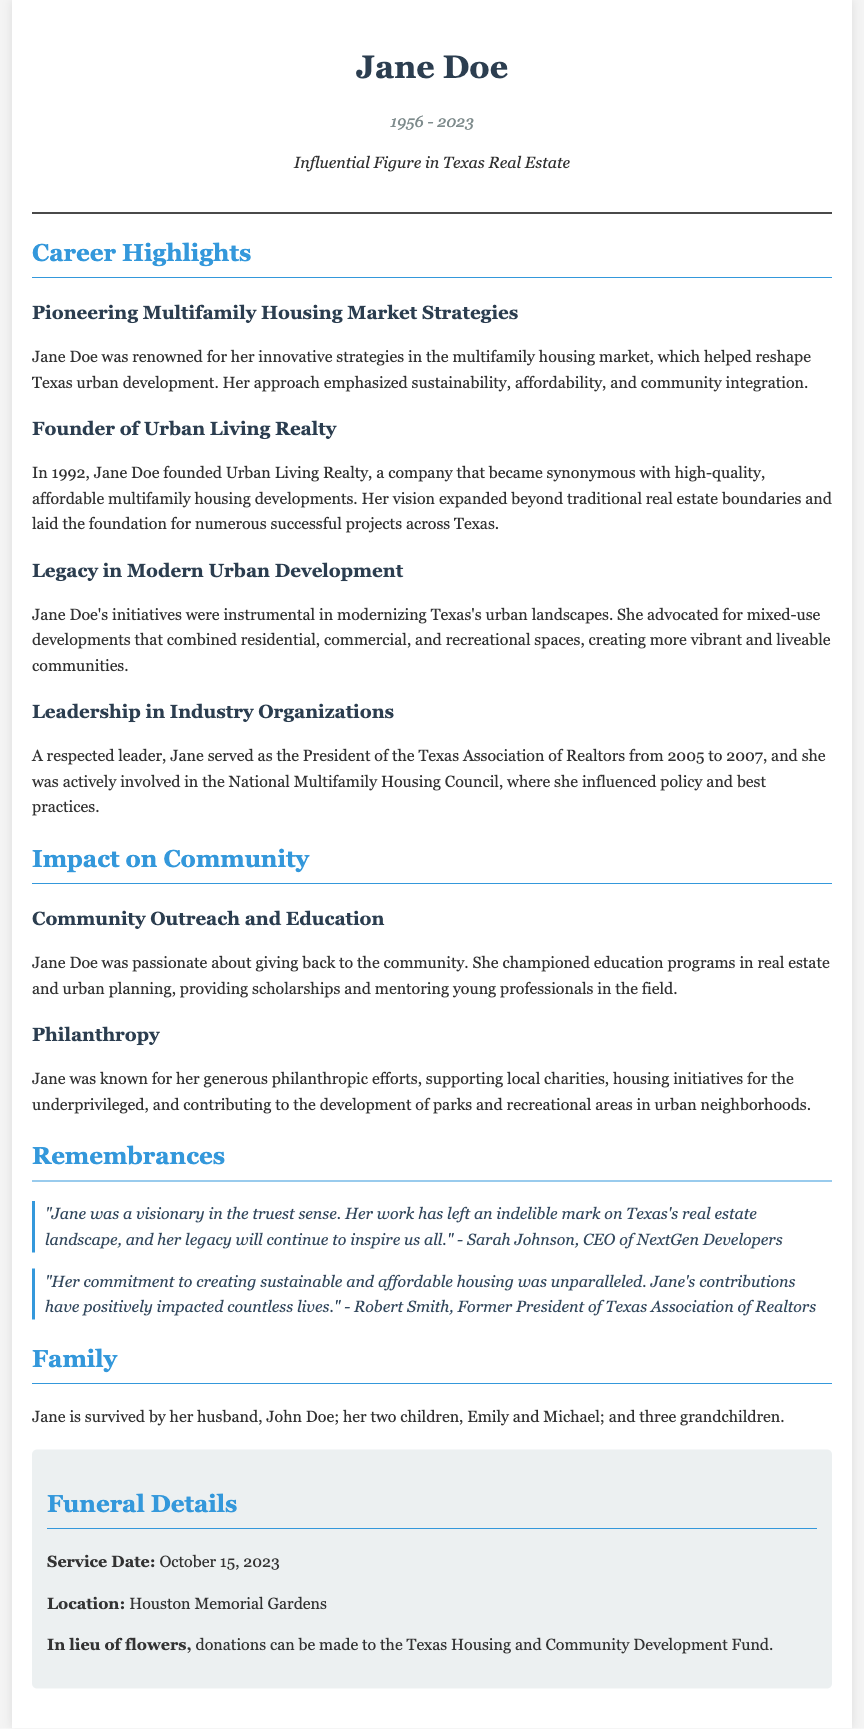What year was Urban Living Realty founded? The document provides that Jane Doe founded Urban Living Realty in 1992.
Answer: 1992 What role did Jane Doe hold in the Texas Association of Realtors? The document states that Jane served as the President of the Texas Association of Realtors.
Answer: President What was one of Jane Doe's key focuses in her multifamily housing strategies? The document mentions that her strategies emphasized sustainability.
Answer: Sustainability What is the date of Jane Doe's service? The document specifies that the service date is October 15, 2023.
Answer: October 15, 2023 Who is quoted expressing admiration for Jane's visions? The document cites Sarah Johnson, CEO of NextGen Developers, in a quote about Jane.
Answer: Sarah Johnson How many grandchildren does Jane Doe have? The document states that Jane is survived by three grandchildren.
Answer: Three What kind of developments did Jane Doe advocate for? The document indicates that she advocated for mixed-use developments.
Answer: Mixed-use developments Which foundation can donations be made to in lieu of flowers? The document mentions donations can be made to the Texas Housing and Community Development Fund.
Answer: Texas Housing and Community Development Fund 